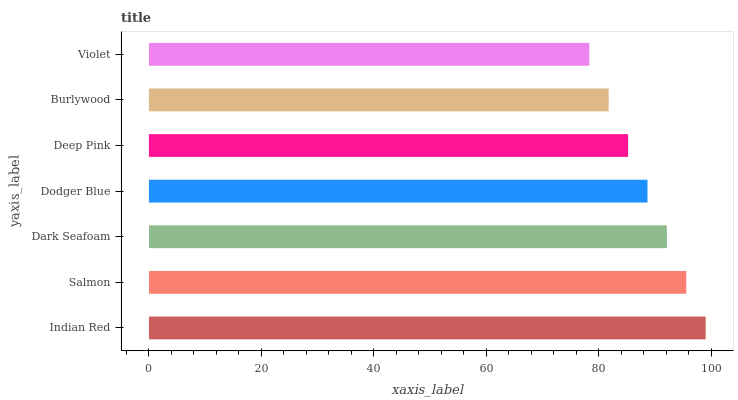Is Violet the minimum?
Answer yes or no. Yes. Is Indian Red the maximum?
Answer yes or no. Yes. Is Salmon the minimum?
Answer yes or no. No. Is Salmon the maximum?
Answer yes or no. No. Is Indian Red greater than Salmon?
Answer yes or no. Yes. Is Salmon less than Indian Red?
Answer yes or no. Yes. Is Salmon greater than Indian Red?
Answer yes or no. No. Is Indian Red less than Salmon?
Answer yes or no. No. Is Dodger Blue the high median?
Answer yes or no. Yes. Is Dodger Blue the low median?
Answer yes or no. Yes. Is Salmon the high median?
Answer yes or no. No. Is Dark Seafoam the low median?
Answer yes or no. No. 